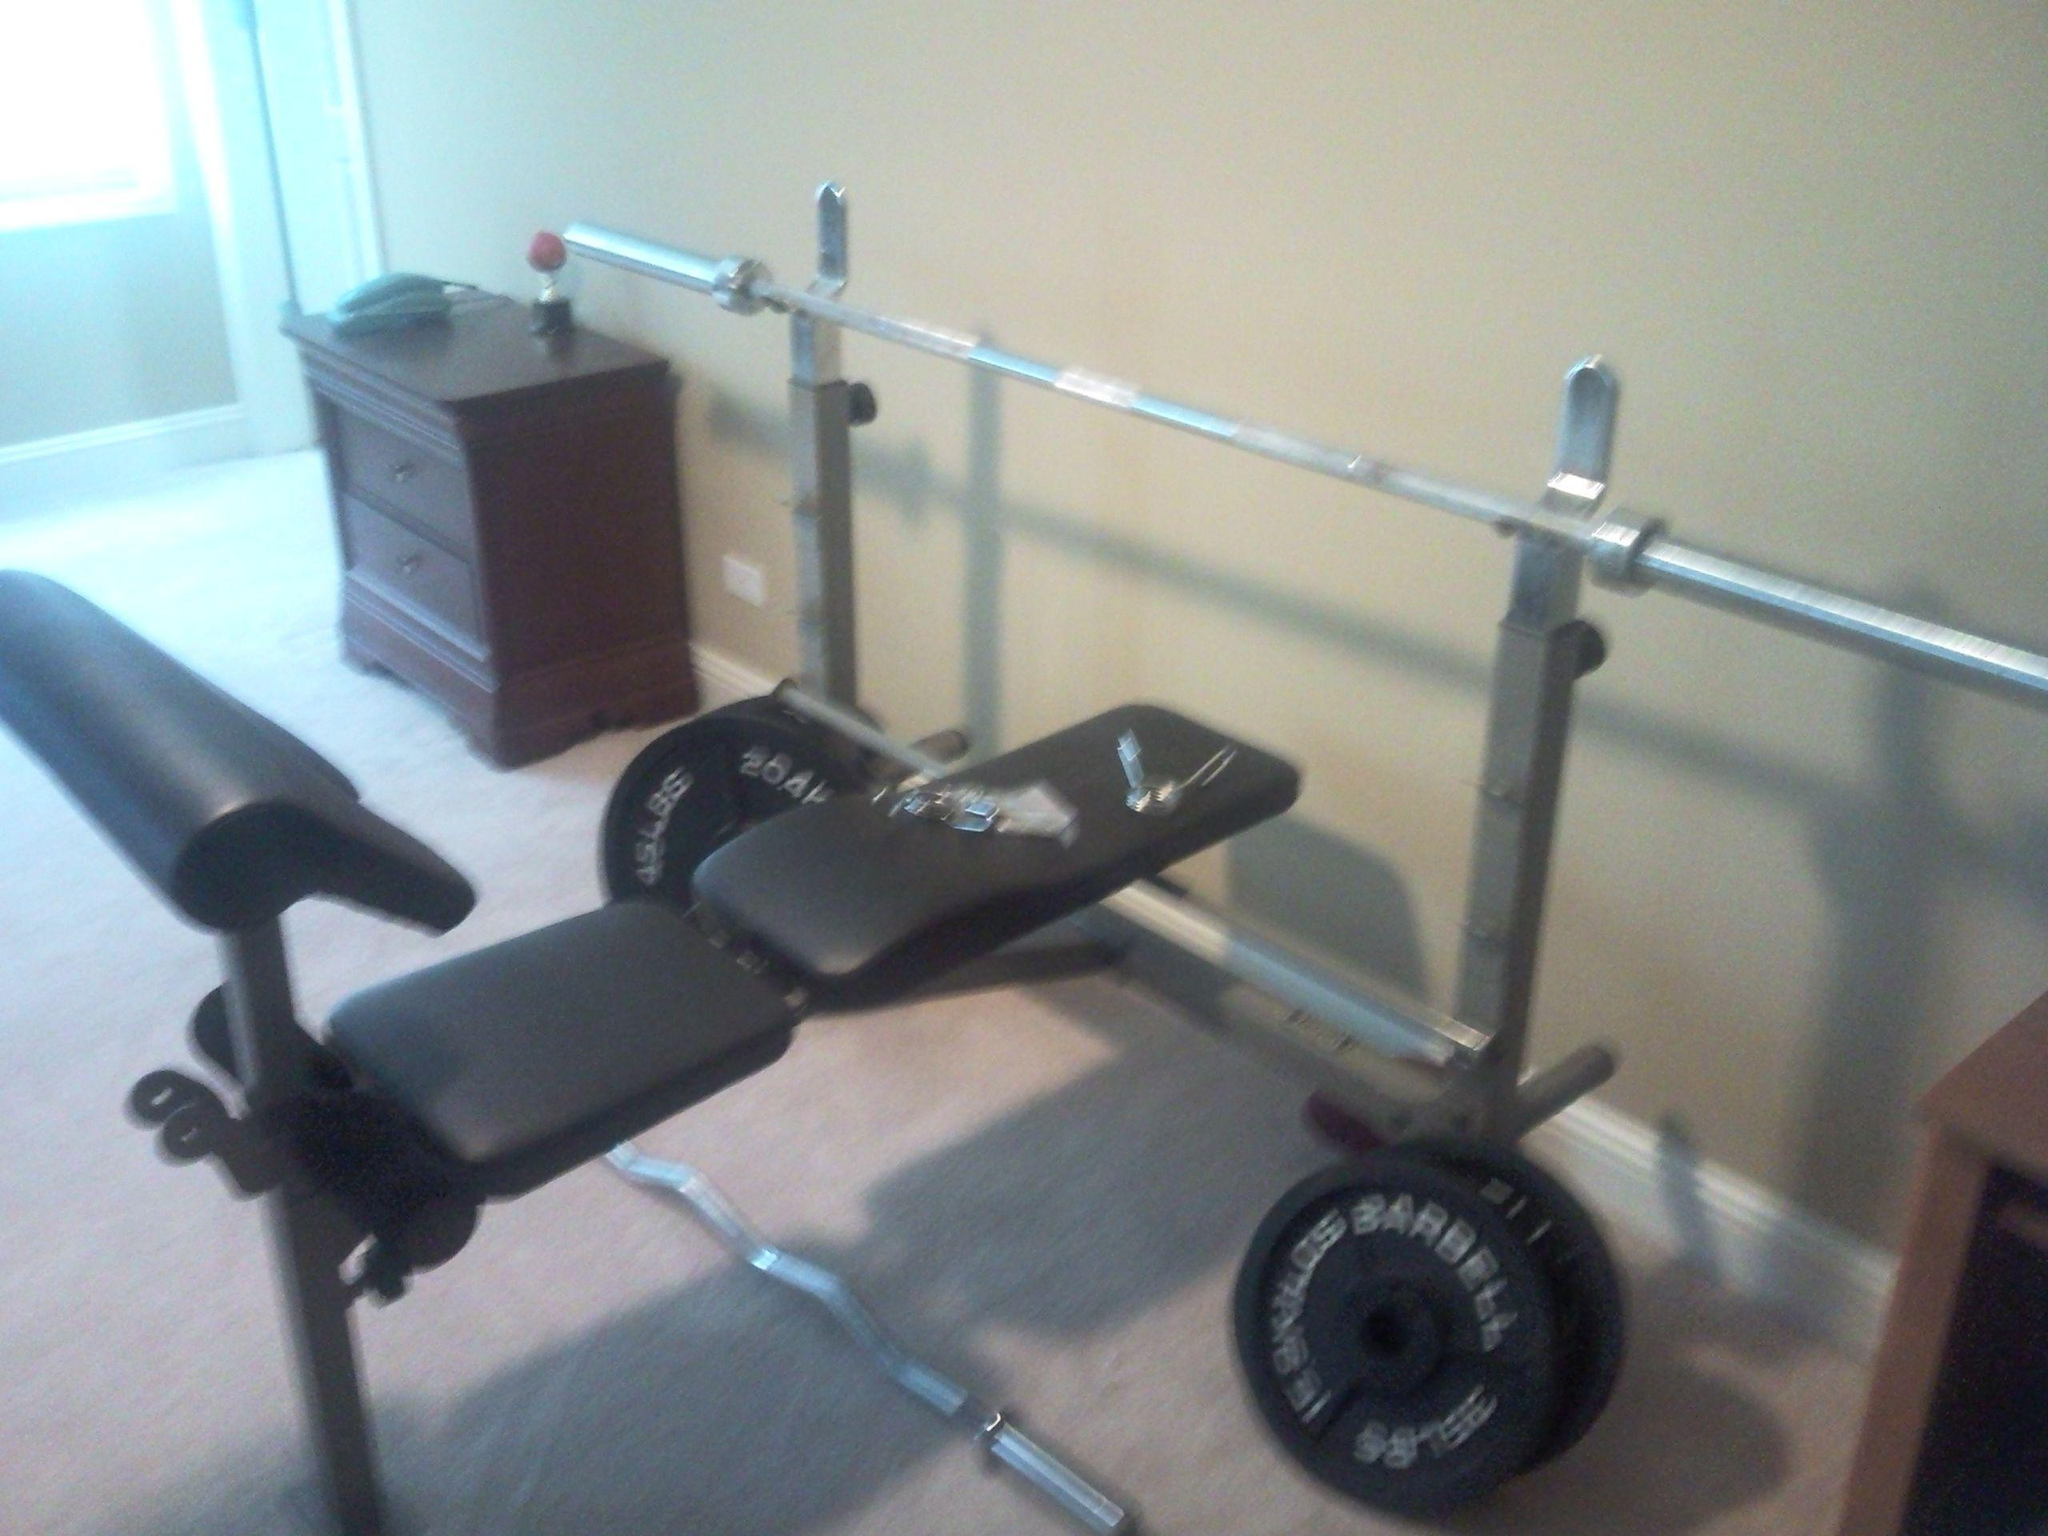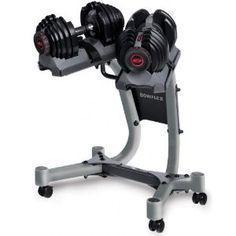The first image is the image on the left, the second image is the image on the right. Examine the images to the left and right. Is the description "Each image contains at least ten black dumbbells, and at least one image shows dumbbells stored on a rack." accurate? Answer yes or no. No. The first image is the image on the left, the second image is the image on the right. Given the left and right images, does the statement "In at least one image there is a bar for a bench that has no weights on it." hold true? Answer yes or no. Yes. 